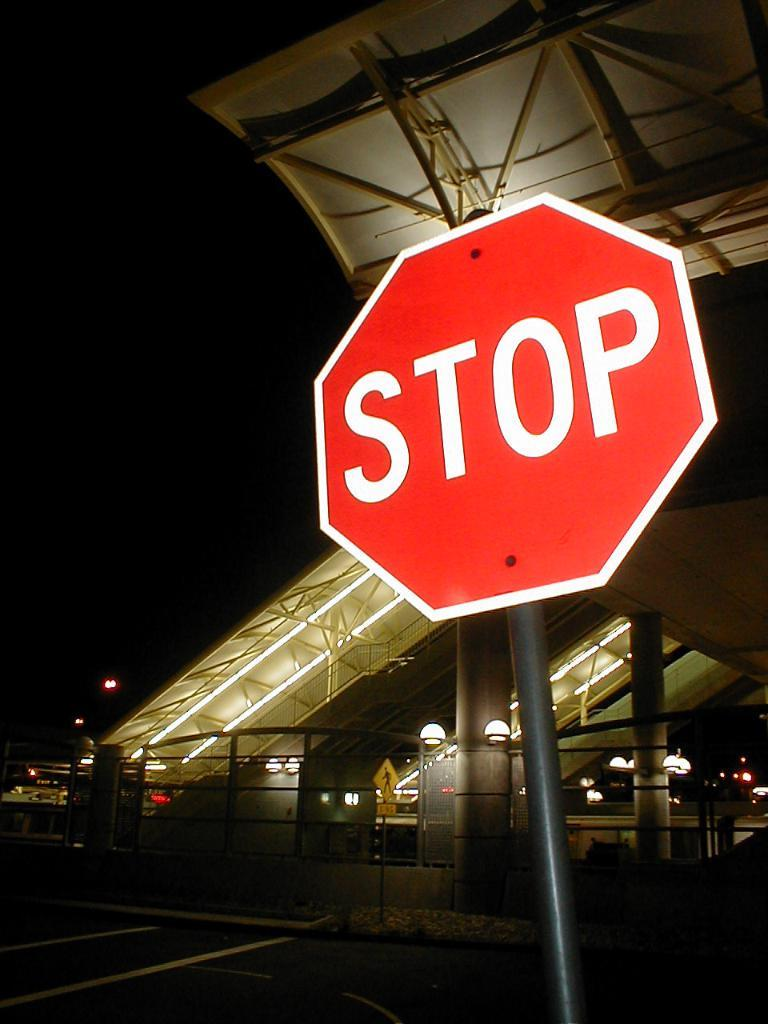<image>
Summarize the visual content of the image. a stop sign that is next to some lit escalators 